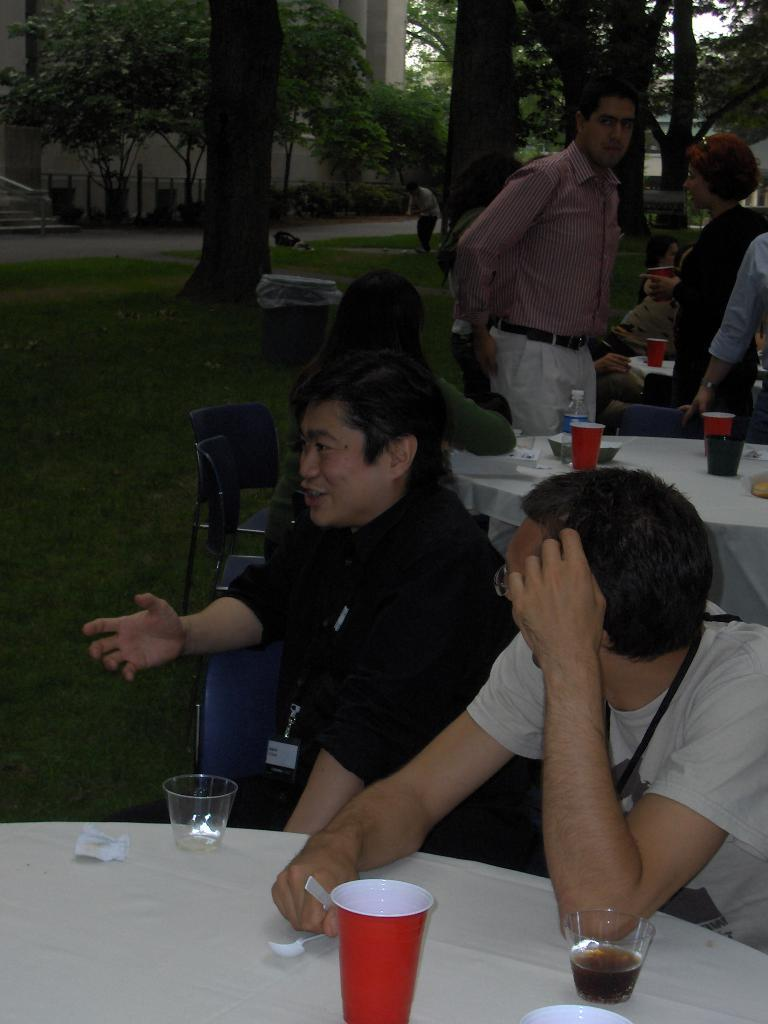What are the people in the image doing? The people in the image are sitting on chairs. How are the chairs arranged in the image? The chairs are arranged around a table. What can be found on the table in the image? There are cups, glasses, and bottles on the table. What is visible in the background of the image? There is a building and trees visible in the background of the image. What type of cart is being used by the people in the image? There is no cart present in the image; the people are sitting on chairs around a table. Can you describe the desk that the people are working on in the image? There is no desk present in the image; the people are sitting around a table with cups, glasses, and bottles. 